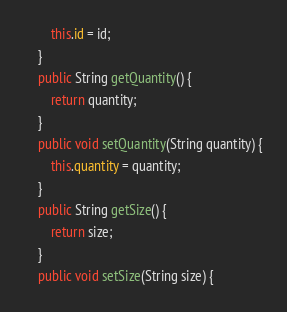<code> <loc_0><loc_0><loc_500><loc_500><_Java_>		this.id = id;
	}
	public String getQuantity() {
		return quantity;
	}
	public void setQuantity(String quantity) {
		this.quantity = quantity;
	}
	public String getSize() {
		return size;
	}
	public void setSize(String size) {</code> 